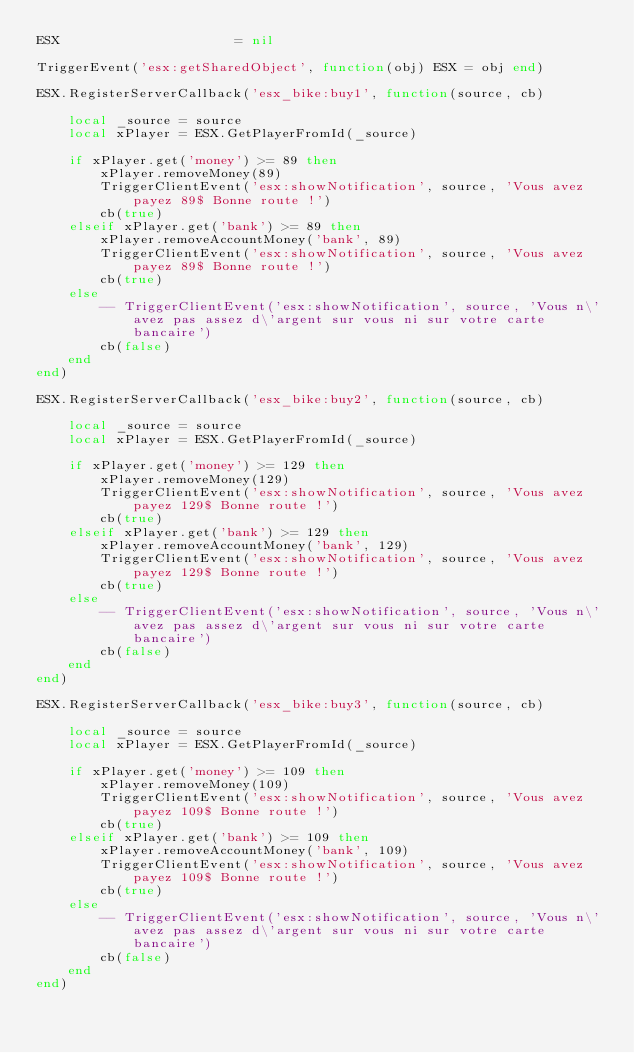<code> <loc_0><loc_0><loc_500><loc_500><_Lua_>ESX                			 = nil

TriggerEvent('esx:getSharedObject', function(obj) ESX = obj end)

ESX.RegisterServerCallback('esx_bike:buy1', function(source, cb)

    local _source = source
    local xPlayer = ESX.GetPlayerFromId(_source)

    if xPlayer.get('money') >= 89 then
        xPlayer.removeMoney(89)
        TriggerClientEvent('esx:showNotification', source, 'Vous avez payez 89$ Bonne route !')
        cb(true)
    elseif xPlayer.get('bank') >= 89 then
        xPlayer.removeAccountMoney('bank', 89)
        TriggerClientEvent('esx:showNotification', source, 'Vous avez payez 89$ Bonne route !')
        cb(true)
    else
        -- TriggerClientEvent('esx:showNotification', source, 'Vous n\'avez pas assez d\'argent sur vous ni sur votre carte bancaire')
        cb(false)
    end
end)

ESX.RegisterServerCallback('esx_bike:buy2', function(source, cb)

    local _source = source
    local xPlayer = ESX.GetPlayerFromId(_source)

    if xPlayer.get('money') >= 129 then
        xPlayer.removeMoney(129)
        TriggerClientEvent('esx:showNotification', source, 'Vous avez payez 129$ Bonne route !')
        cb(true)
    elseif xPlayer.get('bank') >= 129 then
        xPlayer.removeAccountMoney('bank', 129)
        TriggerClientEvent('esx:showNotification', source, 'Vous avez payez 129$ Bonne route !')
        cb(true)
    else
        -- TriggerClientEvent('esx:showNotification', source, 'Vous n\'avez pas assez d\'argent sur vous ni sur votre carte bancaire')
        cb(false)
    end
end)

ESX.RegisterServerCallback('esx_bike:buy3', function(source, cb)

    local _source = source
    local xPlayer = ESX.GetPlayerFromId(_source)

    if xPlayer.get('money') >= 109 then
        xPlayer.removeMoney(109)
        TriggerClientEvent('esx:showNotification', source, 'Vous avez payez 109$ Bonne route !')
        cb(true)
    elseif xPlayer.get('bank') >= 109 then
        xPlayer.removeAccountMoney('bank', 109)
        TriggerClientEvent('esx:showNotification', source, 'Vous avez payez 109$ Bonne route !')
        cb(true)
    else
        -- TriggerClientEvent('esx:showNotification', source, 'Vous n\'avez pas assez d\'argent sur vous ni sur votre carte bancaire')
        cb(false)
    end
end)</code> 